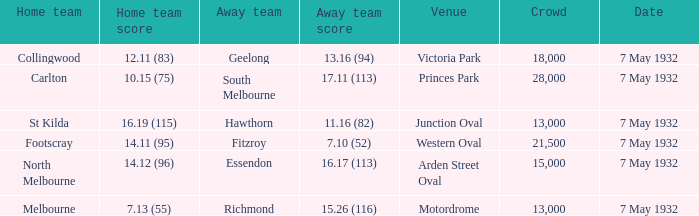12 (96)? 15000.0. 